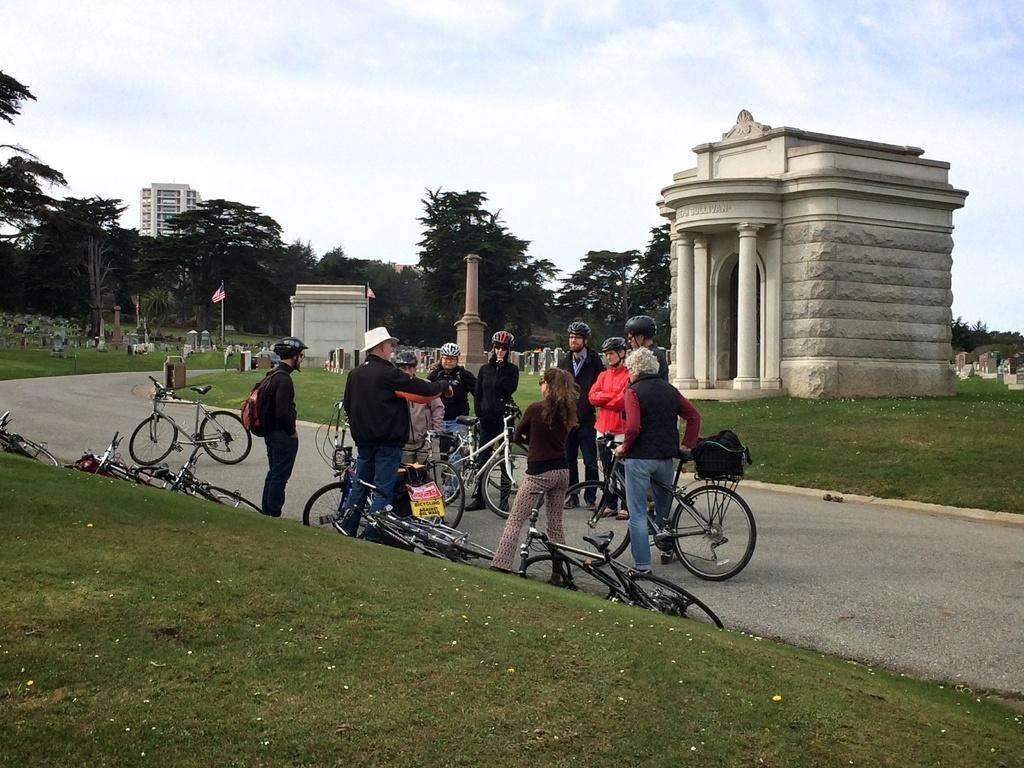Please provide a concise description of this image. In the middle of this image, there are persons and bicycles on the road. Some of these persons are holding bicycles. On both sides of this road, there is grass. In the background, there are trees, a building, a pole, a flag and other objects on the ground and there are clouds in the blue sky. 